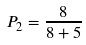Convert formula to latex. <formula><loc_0><loc_0><loc_500><loc_500>P _ { 2 } = \frac { 8 } { 8 + 5 }</formula> 